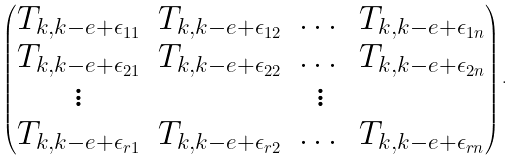<formula> <loc_0><loc_0><loc_500><loc_500>\begin{pmatrix} T _ { k , k - e + \epsilon _ { 1 1 } } & T _ { k , k - e + \epsilon _ { 1 2 } } & \dots & T _ { k , k - e + \epsilon _ { 1 n } } \\ T _ { k , k - e + \epsilon _ { 2 1 } } & T _ { k , k - e + \epsilon _ { 2 2 } } & \dots & T _ { k , k - e + \epsilon _ { 2 n } } \\ \vdots & & \vdots \\ T _ { k , k - e + \epsilon _ { r 1 } } & T _ { k , k - e + \epsilon _ { r 2 } } & \dots & T _ { k , k - e + \epsilon _ { r n } } \end{pmatrix} .</formula> 